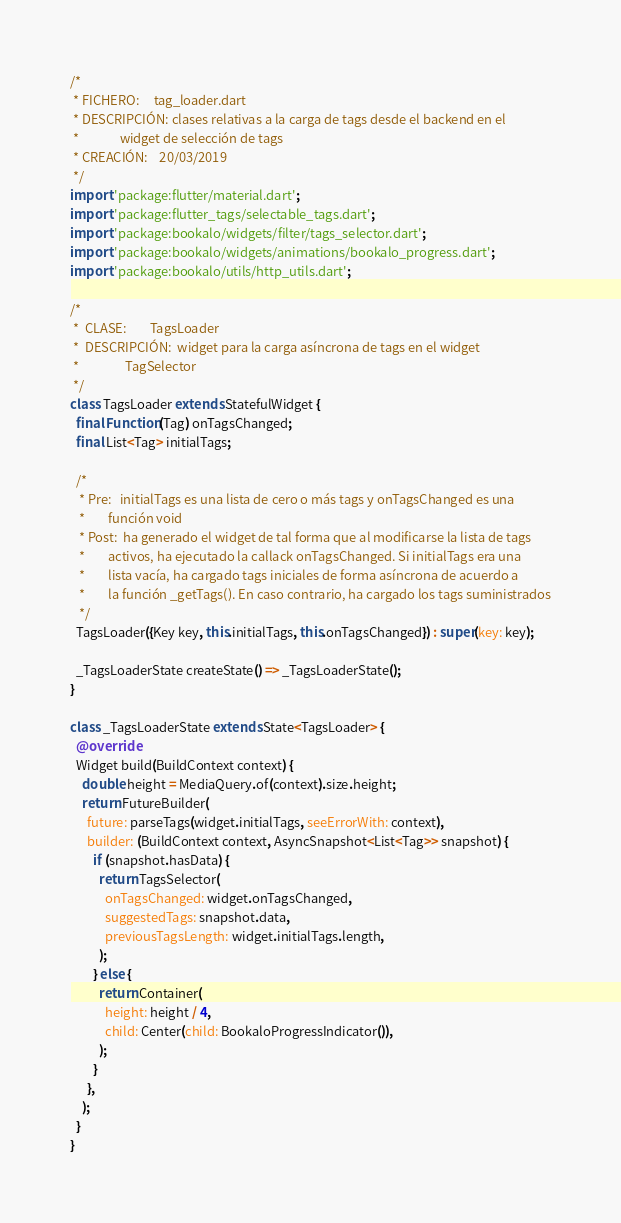Convert code to text. <code><loc_0><loc_0><loc_500><loc_500><_Dart_>/*
 * FICHERO:     tag_loader.dart
 * DESCRIPCIÓN: clases relativas a la carga de tags desde el backend en el
 *              widget de selección de tags
 * CREACIÓN:    20/03/2019
 */
import 'package:flutter/material.dart';
import 'package:flutter_tags/selectable_tags.dart';
import 'package:bookalo/widgets/filter/tags_selector.dart';
import 'package:bookalo/widgets/animations/bookalo_progress.dart';
import 'package:bookalo/utils/http_utils.dart';

/*
 *  CLASE:        TagsLoader
 *  DESCRIPCIÓN:  widget para la carga asíncrona de tags en el widget
 *                TagSelector
 */
class TagsLoader extends StatefulWidget {
  final Function(Tag) onTagsChanged;
  final List<Tag> initialTags;

  /*
   * Pre:   initialTags es una lista de cero o más tags y onTagsChanged es una
   *        función void
   * Post:  ha generado el widget de tal forma que al modificarse la lista de tags
   *        activos, ha ejecutado la callack onTagsChanged. Si initialTags era una
   *        lista vacía, ha cargado tags iniciales de forma asíncrona de acuerdo a
   *        la función _getTags(). En caso contrario, ha cargado los tags suministrados
   */
  TagsLoader({Key key, this.initialTags, this.onTagsChanged}) : super(key: key);

  _TagsLoaderState createState() => _TagsLoaderState();
}

class _TagsLoaderState extends State<TagsLoader> {
  @override
  Widget build(BuildContext context) {
    double height = MediaQuery.of(context).size.height;
    return FutureBuilder(
      future: parseTags(widget.initialTags, seeErrorWith: context),
      builder: (BuildContext context, AsyncSnapshot<List<Tag>> snapshot) {
        if (snapshot.hasData) {
          return TagsSelector(
            onTagsChanged: widget.onTagsChanged,
            suggestedTags: snapshot.data,
            previousTagsLength: widget.initialTags.length,
          );
        } else {
          return Container(
            height: height / 4,
            child: Center(child: BookaloProgressIndicator()),
          );
        }
      },
    );
  }
}
</code> 